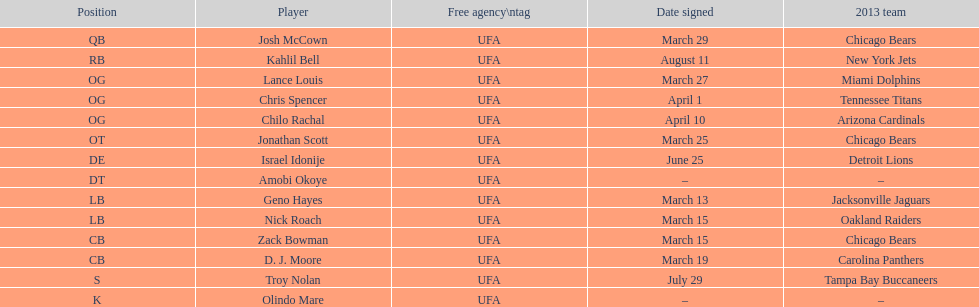The only player to sign in july? Troy Nolan. 